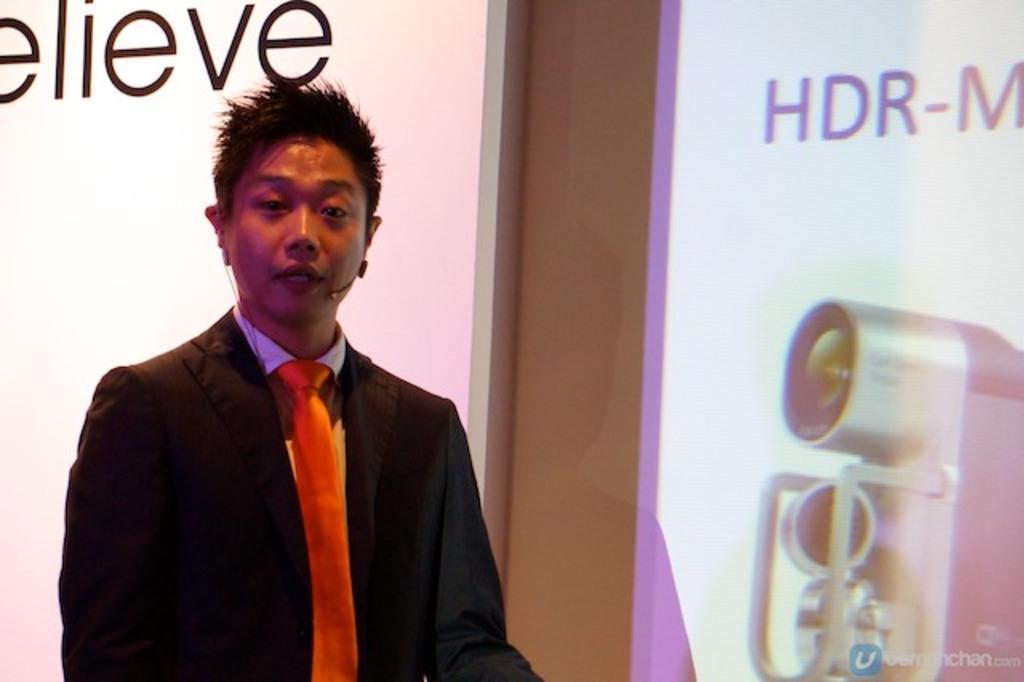How would you summarize this image in a sentence or two? here we see a person standing and speaking with the help of a microphone and there is an advertising hoarding back of him and to the right side of him 